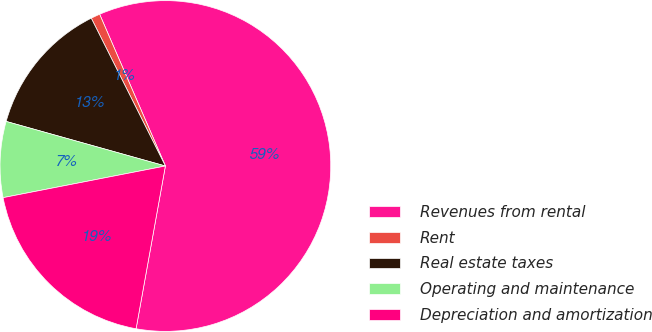<chart> <loc_0><loc_0><loc_500><loc_500><pie_chart><fcel>Revenues from rental<fcel>Rent<fcel>Real estate taxes<fcel>Operating and maintenance<fcel>Depreciation and amortization<nl><fcel>59.35%<fcel>0.89%<fcel>13.26%<fcel>7.41%<fcel>19.1%<nl></chart> 